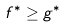<formula> <loc_0><loc_0><loc_500><loc_500>f ^ { * } \geq g ^ { * }</formula> 